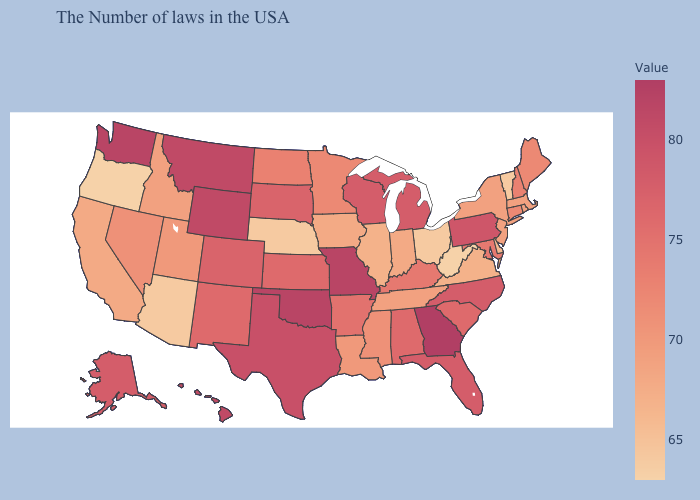Is the legend a continuous bar?
Give a very brief answer. Yes. Does the map have missing data?
Answer briefly. No. Does North Carolina have a higher value than Kentucky?
Give a very brief answer. Yes. Does the map have missing data?
Answer briefly. No. Does New York have the highest value in the Northeast?
Short answer required. No. 